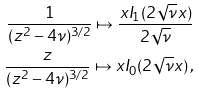Convert formula to latex. <formula><loc_0><loc_0><loc_500><loc_500>\frac { 1 } { ( z ^ { 2 } - 4 \nu ) ^ { 3 / 2 } } \mapsto \frac { x I _ { 1 } ( 2 \sqrt { \nu } x ) } { 2 \sqrt { \nu } } \\ \frac { z } { ( z ^ { 2 } - 4 \nu ) ^ { 3 / 2 } } \mapsto x I _ { 0 } ( 2 \sqrt { \nu } x ) \, ,</formula> 